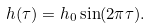<formula> <loc_0><loc_0><loc_500><loc_500>h ( \tau ) = h _ { 0 } \sin ( 2 \pi \tau ) .</formula> 